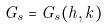<formula> <loc_0><loc_0><loc_500><loc_500>G _ { s } = G _ { s } ( h , k )</formula> 